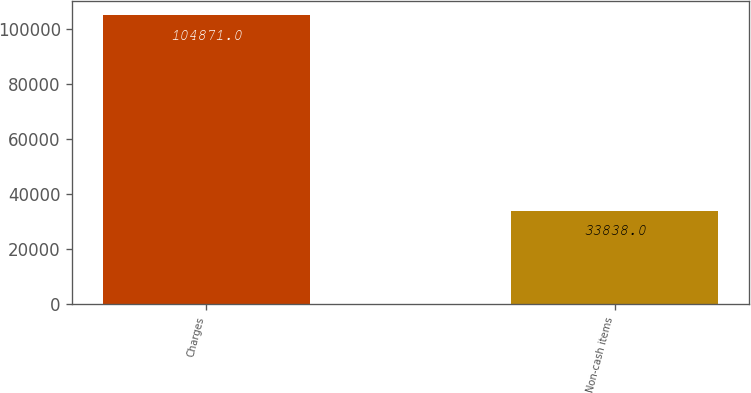Convert chart to OTSL. <chart><loc_0><loc_0><loc_500><loc_500><bar_chart><fcel>Charges<fcel>Non-cash items<nl><fcel>104871<fcel>33838<nl></chart> 